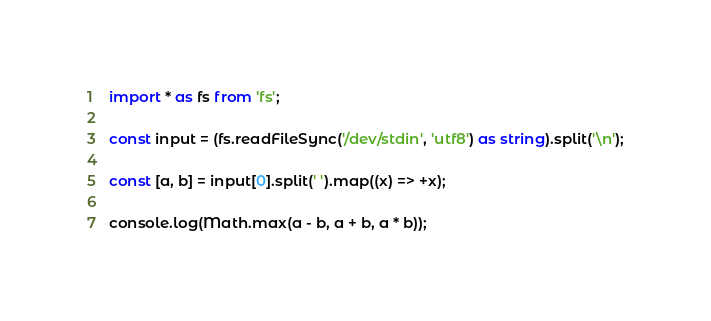Convert code to text. <code><loc_0><loc_0><loc_500><loc_500><_TypeScript_>import * as fs from 'fs';

const input = (fs.readFileSync('/dev/stdin', 'utf8') as string).split('\n');

const [a, b] = input[0].split(' ').map((x) => +x);

console.log(Math.max(a - b, a + b, a * b));
</code> 